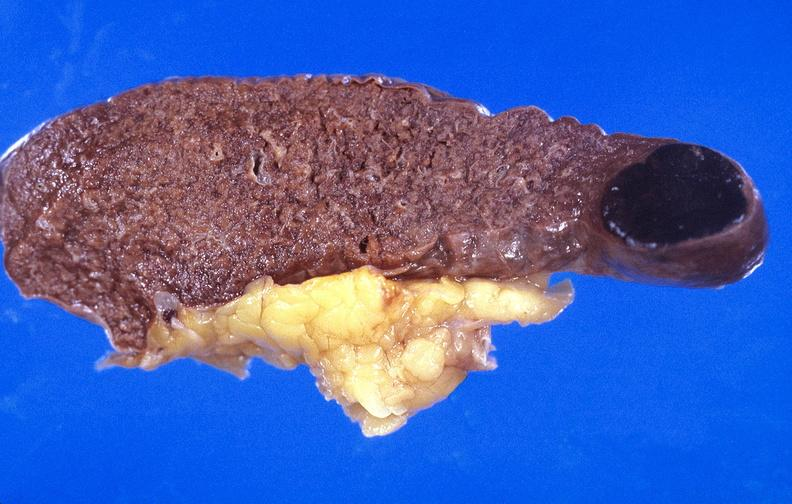does this image show spleen, metastasis of malignant melanoma?
Answer the question using a single word or phrase. Yes 